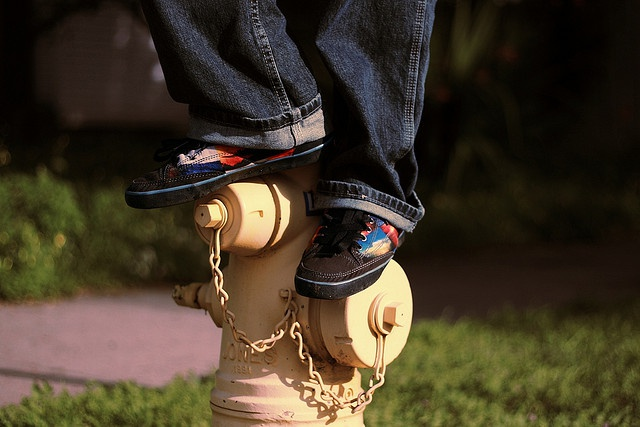Describe the objects in this image and their specific colors. I can see people in black, gray, and darkgray tones and fire hydrant in black, khaki, maroon, and gray tones in this image. 